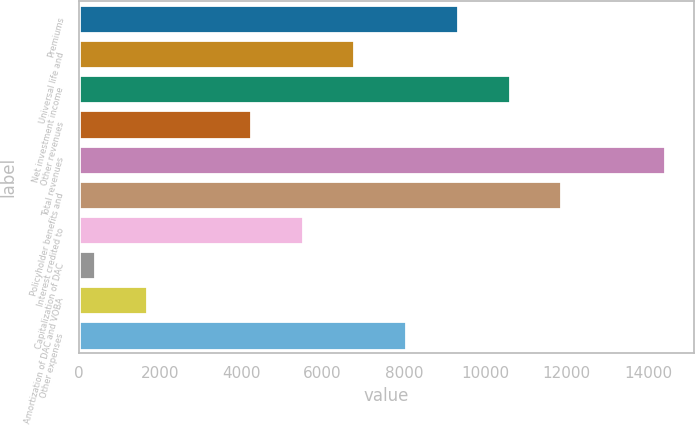Convert chart to OTSL. <chart><loc_0><loc_0><loc_500><loc_500><bar_chart><fcel>Premiums<fcel>Universal life and<fcel>Net investment income<fcel>Other revenues<fcel>Total revenues<fcel>Policyholder benefits and<fcel>Interest credited to<fcel>Capitalization of DAC<fcel>Amortization of DAC and VOBA<fcel>Other expenses<nl><fcel>9325.2<fcel>6778<fcel>10598.8<fcel>4230.8<fcel>14419.6<fcel>11872.4<fcel>5504.4<fcel>410<fcel>1683.6<fcel>8051.6<nl></chart> 